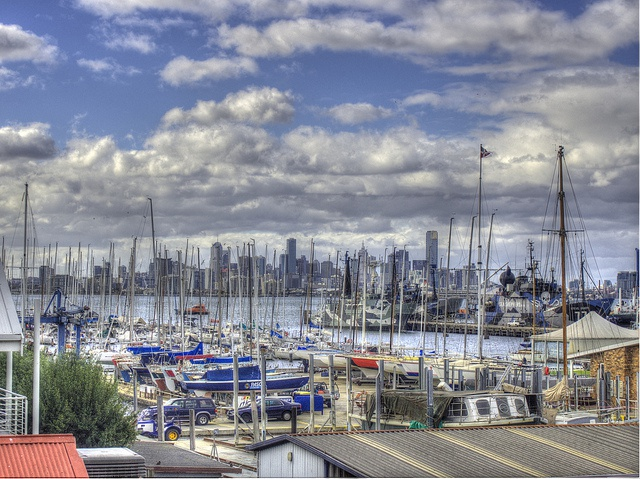Describe the objects in this image and their specific colors. I can see boat in gray, darkgray, and lightgray tones, boat in gray, darkgray, black, and lightgray tones, boat in gray, black, darkgray, and navy tones, boat in gray, navy, darkgray, and lightgray tones, and boat in gray, darkgray, and lightgray tones in this image. 